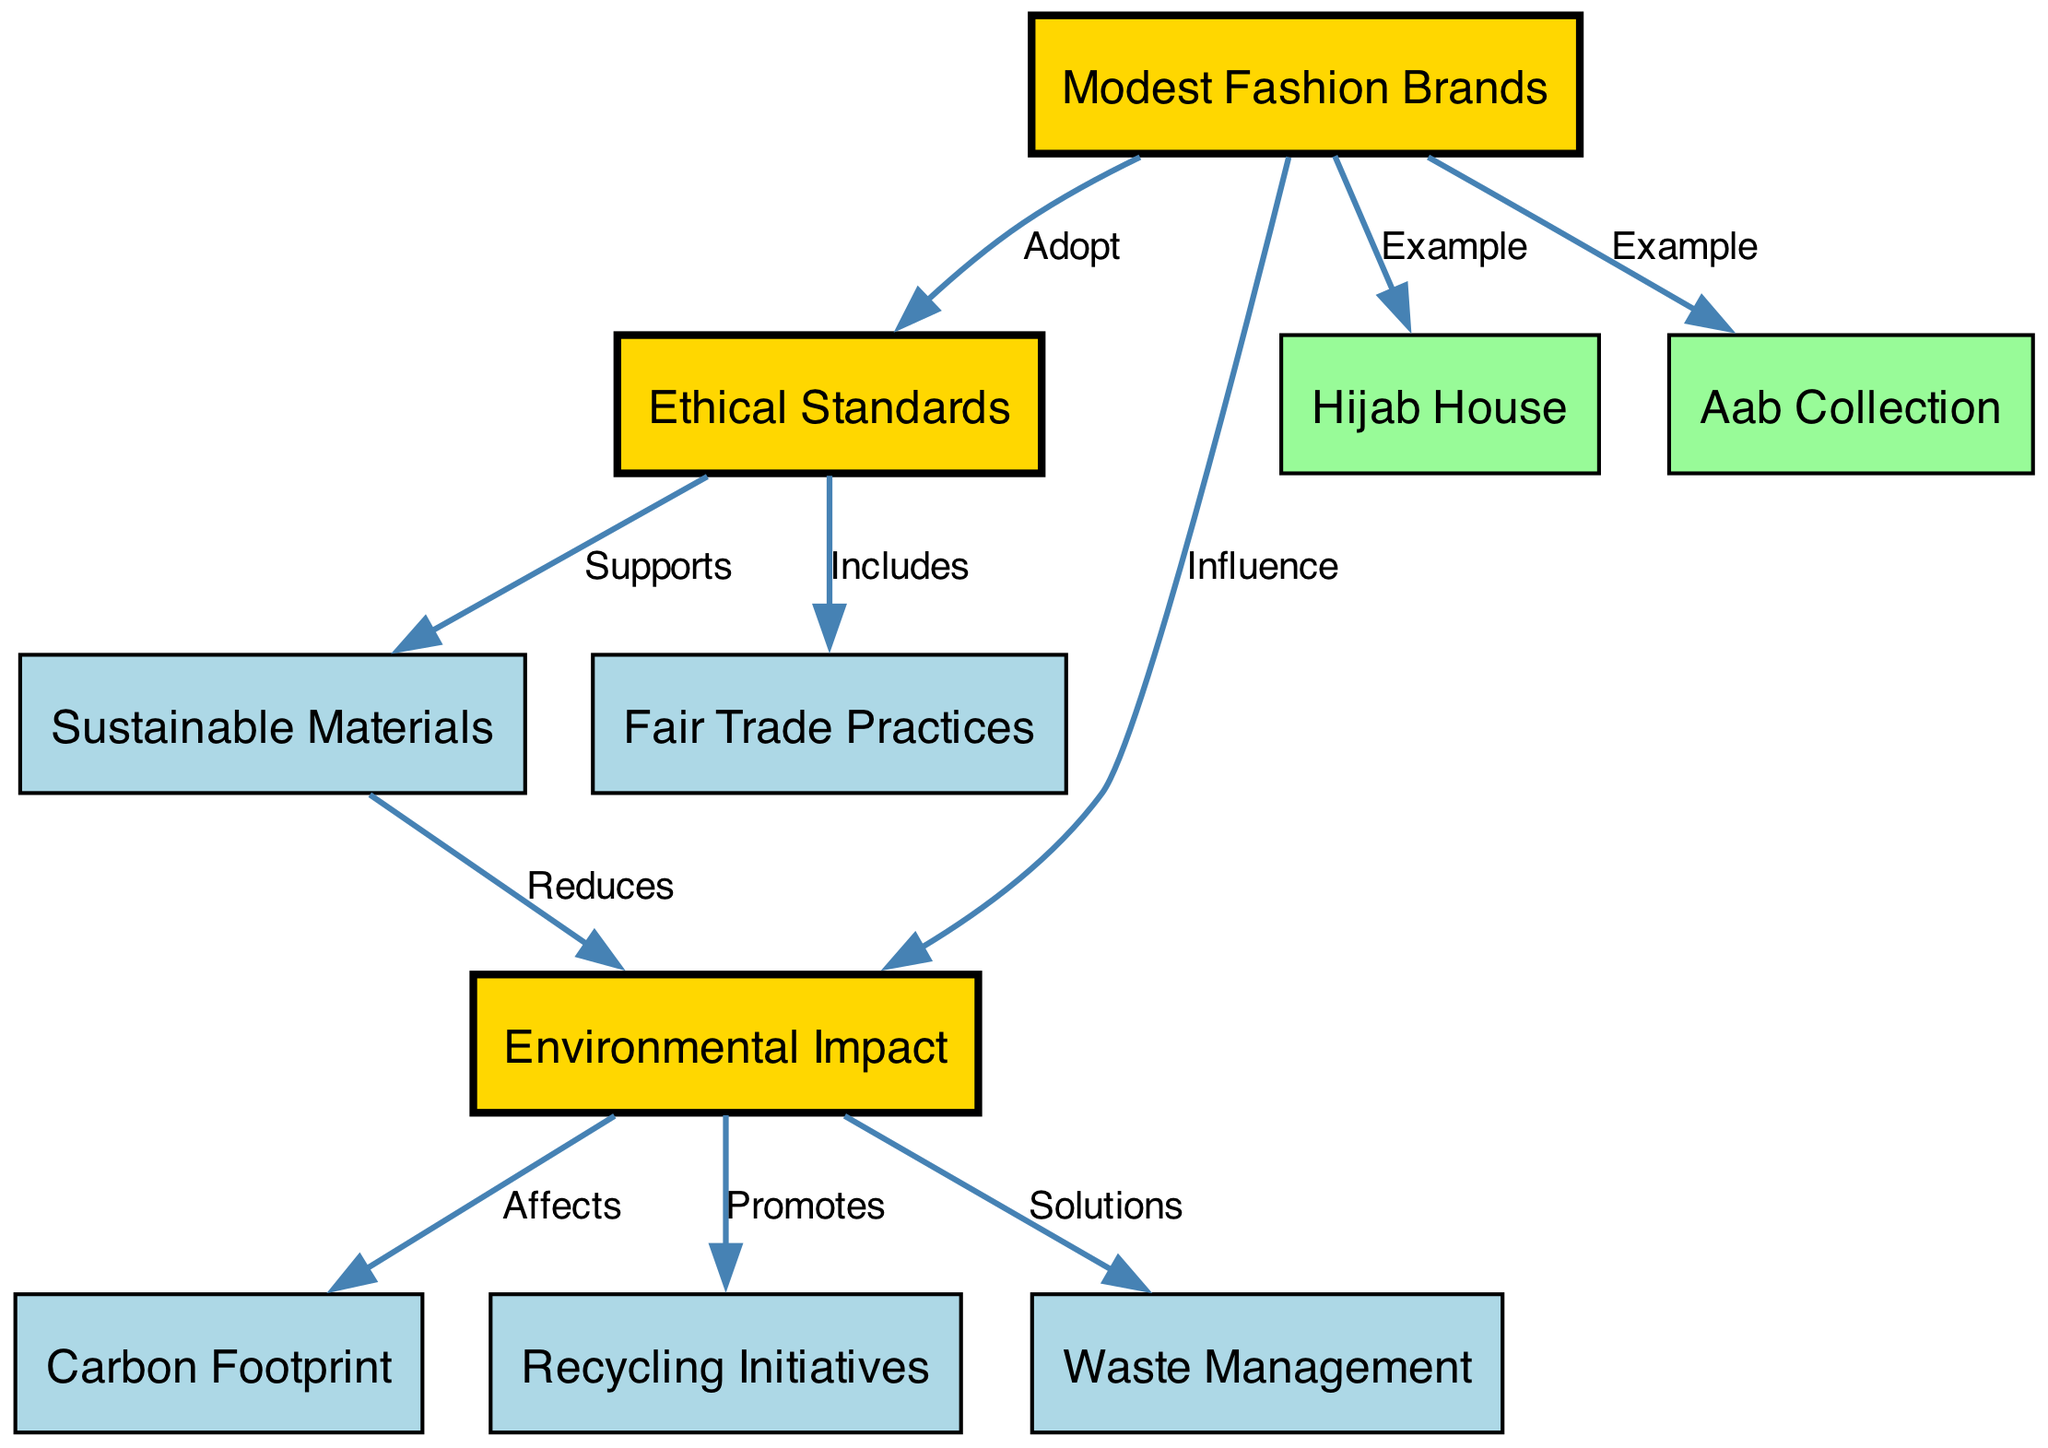What are the two examples of modest fashion brands listed? The diagram specifically points out two examples under the modest fashion brands node, which are "Hijab House" and "Aab Collection."
Answer: Hijab House, Aab Collection What relationship does "sustainable materials" have with "ethical standards"? The diagram indicates that sustainable materials are supported by ethical standards, showcasing how ethical practices enhance the use of sustainable materials in modest fashion.
Answer: Supports How many nodes are present in the diagram? To find the total number of nodes, we can count all unique entities connected in the diagram, which totals to ten nodes listed in the data provided.
Answer: 10 What is the effect of "environmental impact" on "carbon footprint"? According to the diagram, environmental impact directly affects the carbon footprint, illustrating a clear causative relationship between the two concepts.
Answer: Affects Which modest fashion brand is highlighted as an example for sustainable practices? Within the diagram, both Hijab House and Aab Collection are cited as examples under the modest fashion brands node, indicating their emphasis on sustainable practices.
Answer: Hijab House, Aab Collection How do "recycling initiatives" relate to "environmental impact"? The diagram shows that environmental impact promotes recycling initiatives, indicating that efforts towards sustainability enhance recycling practices in the fashion industry.
Answer: Promotes What ethical practice is included under "ethical standards"? The diagram connects ethical standards with fair trade practices, which is a key focus when discussing ethical considerations in fashion brands that hold sustainable practices.
Answer: Fair Trade Practices Which component helps reduce environmental impact? As indicated in the diagram, sustainable materials play a critical role in reducing environmental impact, showing how responsible sourcing benefits the environment.
Answer: Reduces 